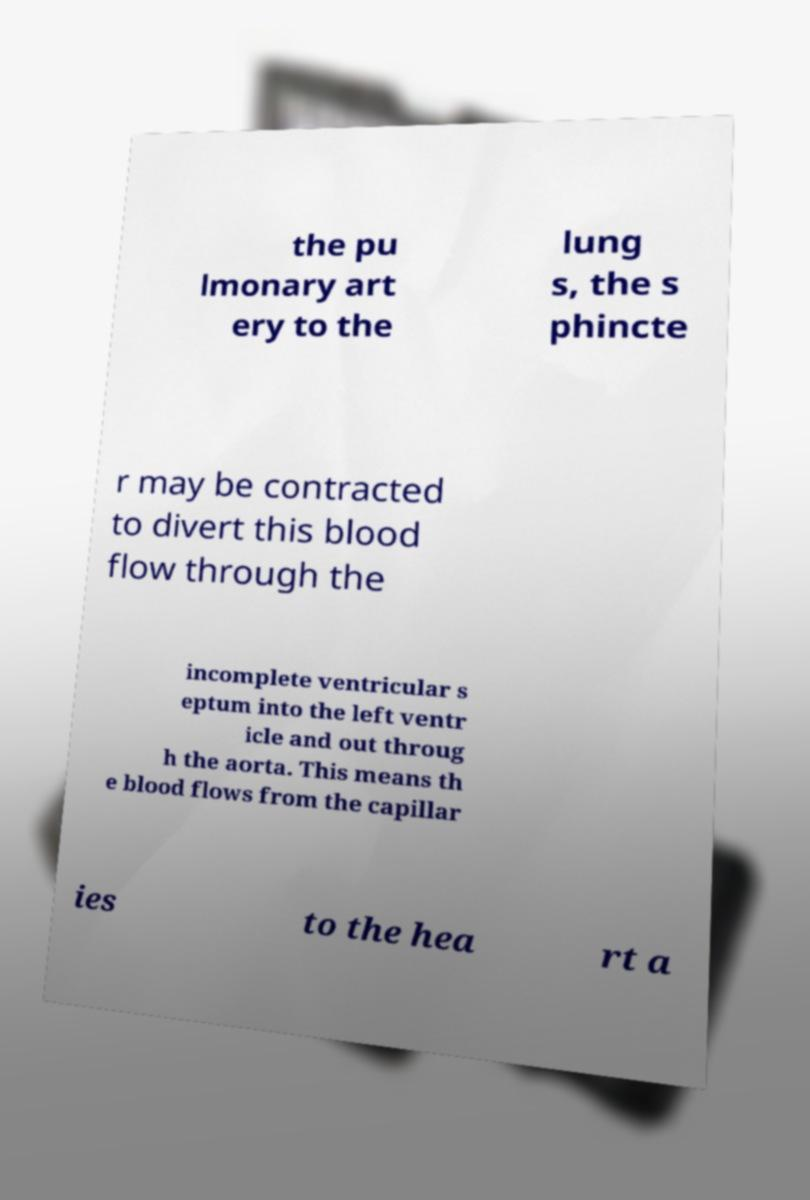What messages or text are displayed in this image? I need them in a readable, typed format. the pu lmonary art ery to the lung s, the s phincte r may be contracted to divert this blood flow through the incomplete ventricular s eptum into the left ventr icle and out throug h the aorta. This means th e blood flows from the capillar ies to the hea rt a 